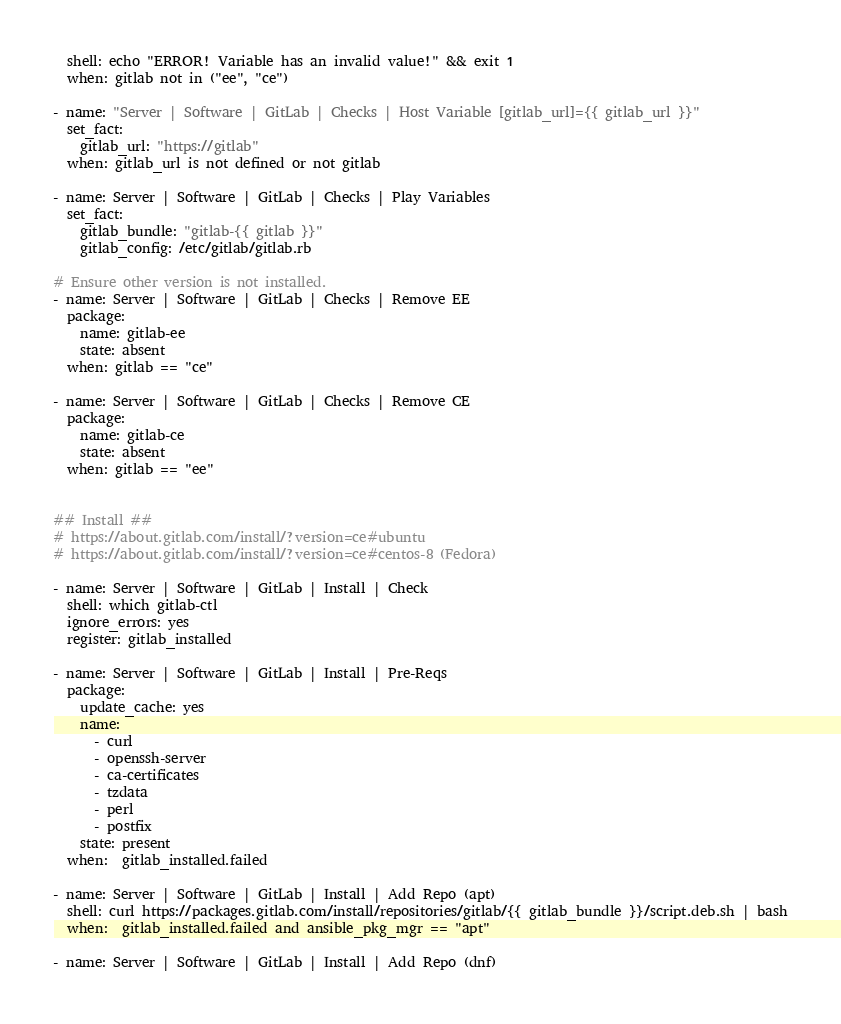<code> <loc_0><loc_0><loc_500><loc_500><_YAML_>  shell: echo "ERROR! Variable has an invalid value!" && exit 1
  when: gitlab not in ("ee", "ce")

- name: "Server | Software | GitLab | Checks | Host Variable [gitlab_url]={{ gitlab_url }}"
  set_fact:
    gitlab_url: "https://gitlab"
  when: gitlab_url is not defined or not gitlab

- name: Server | Software | GitLab | Checks | Play Variables
  set_fact:
    gitlab_bundle: "gitlab-{{ gitlab }}"
    gitlab_config: /etc/gitlab/gitlab.rb

# Ensure other version is not installed.
- name: Server | Software | GitLab | Checks | Remove EE
  package:
    name: gitlab-ee
    state: absent
  when: gitlab == "ce"

- name: Server | Software | GitLab | Checks | Remove CE
  package:
    name: gitlab-ce
    state: absent
  when: gitlab == "ee"


## Install ##
# https://about.gitlab.com/install/?version=ce#ubuntu
# https://about.gitlab.com/install/?version=ce#centos-8 (Fedora)

- name: Server | Software | GitLab | Install | Check
  shell: which gitlab-ctl
  ignore_errors: yes
  register: gitlab_installed

- name: Server | Software | GitLab | Install | Pre-Reqs
  package:
    update_cache: yes
    name: 
      - curl 
      - openssh-server 
      - ca-certificates 
      - tzdata 
      - perl
      - postfix
    state: present 
  when:  gitlab_installed.failed
  
- name: Server | Software | GitLab | Install | Add Repo (apt)
  shell: curl https://packages.gitlab.com/install/repositories/gitlab/{{ gitlab_bundle }}/script.deb.sh | bash
  when:  gitlab_installed.failed and ansible_pkg_mgr == "apt"
  
- name: Server | Software | GitLab | Install | Add Repo (dnf)</code> 